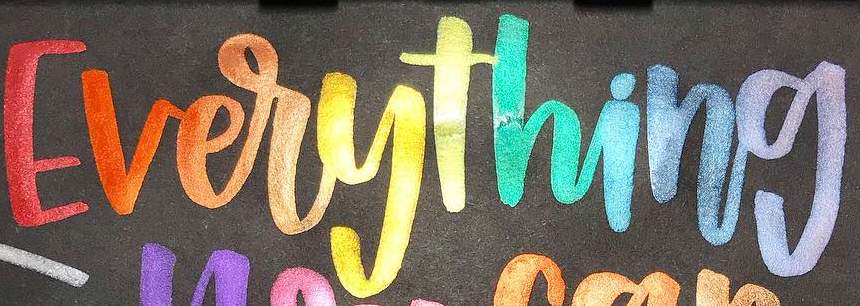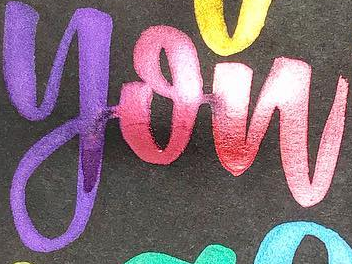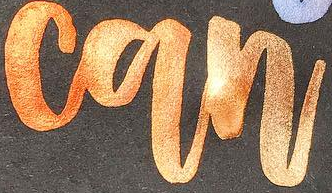What text appears in these images from left to right, separated by a semicolon? Everything; you; can 